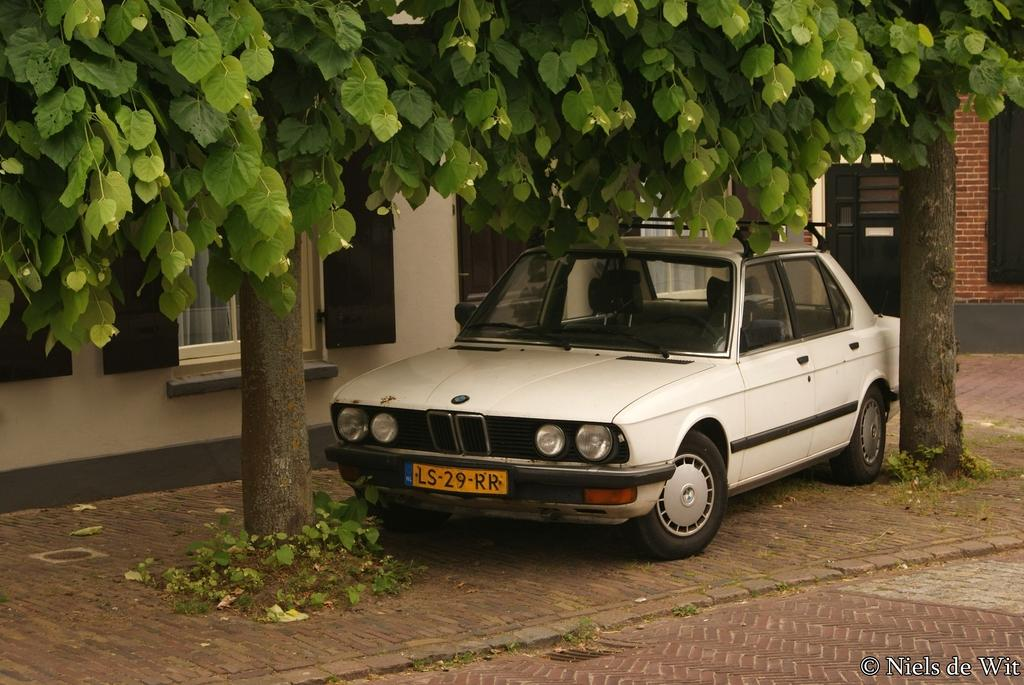What is the main subject of the image? There is a car in the image. What color is the car? The car is white. What can be seen in the background of the image? There are buildings and trees in the background of the image. What colors are the buildings? The buildings are white and brown. What color are the trees? The trees are green. Can you tell me how many needles are sticking out of the car's tires in the image? There are no needles present in the image, and therefore no such activity can be observed. 